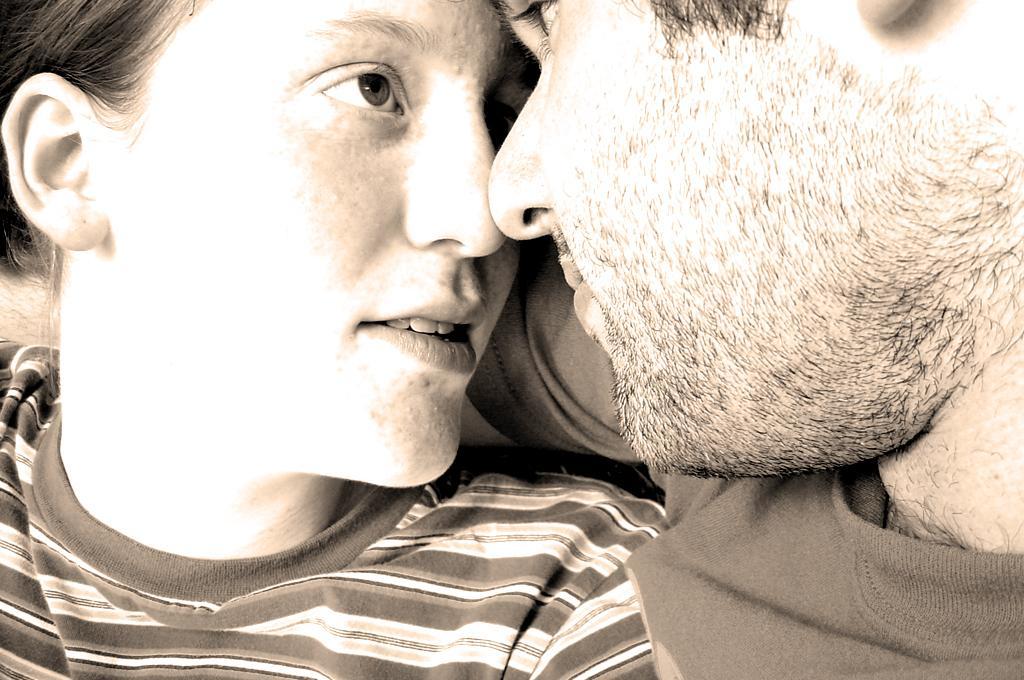How would you summarize this image in a sentence or two? In this image I can see a woman and a man. I can see both of them are wearing t shirts and I can see this image is little bit in brown and white colour. 